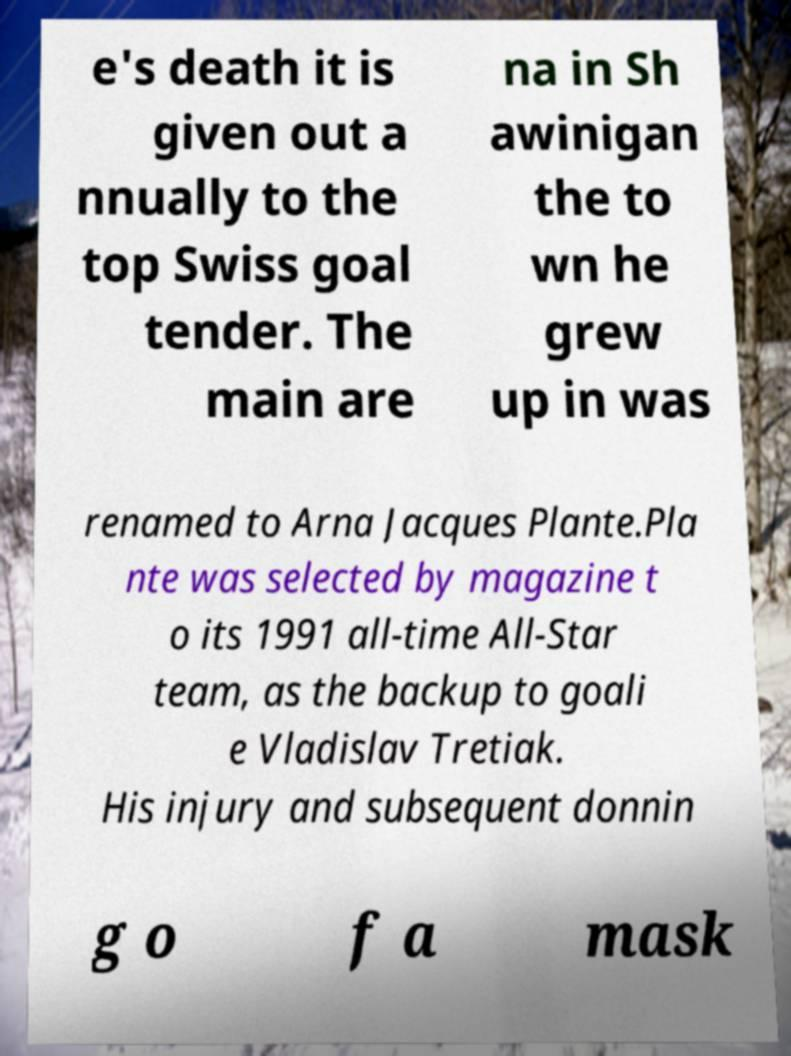Can you accurately transcribe the text from the provided image for me? e's death it is given out a nnually to the top Swiss goal tender. The main are na in Sh awinigan the to wn he grew up in was renamed to Arna Jacques Plante.Pla nte was selected by magazine t o its 1991 all-time All-Star team, as the backup to goali e Vladislav Tretiak. His injury and subsequent donnin g o f a mask 